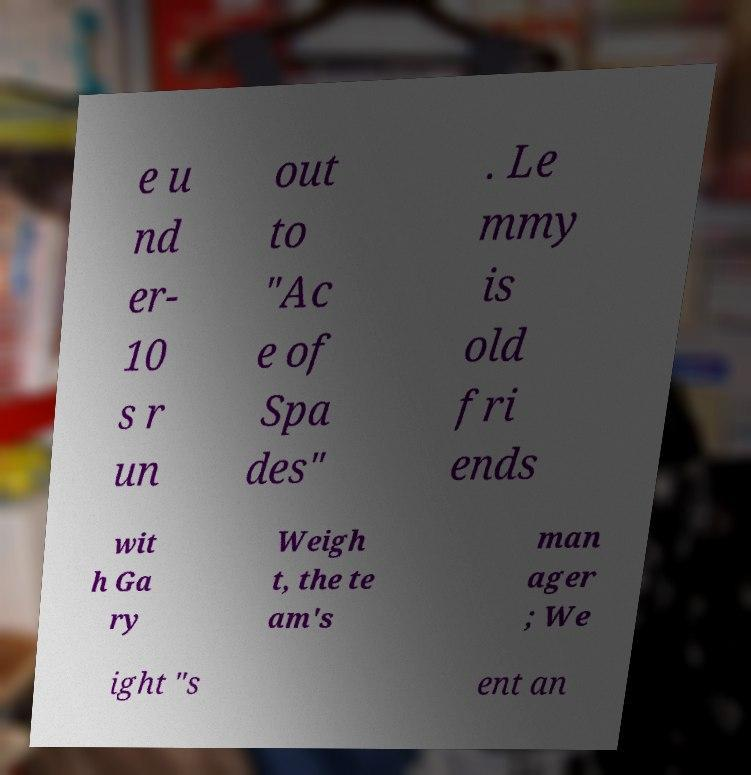Can you read and provide the text displayed in the image?This photo seems to have some interesting text. Can you extract and type it out for me? e u nd er- 10 s r un out to "Ac e of Spa des" . Le mmy is old fri ends wit h Ga ry Weigh t, the te am's man ager ; We ight "s ent an 